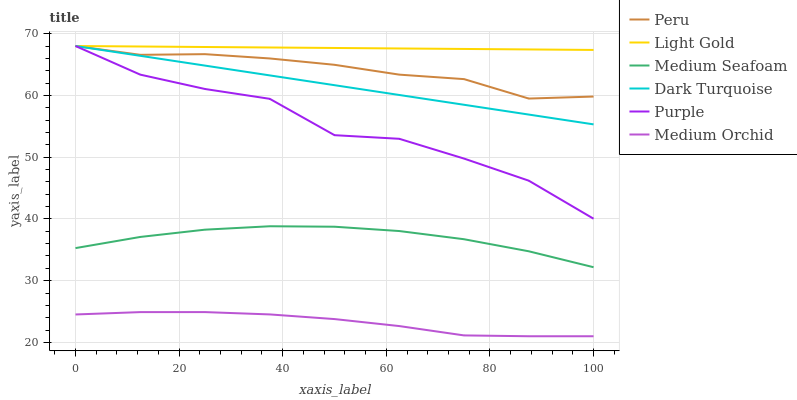Does Medium Orchid have the minimum area under the curve?
Answer yes or no. Yes. Does Light Gold have the maximum area under the curve?
Answer yes or no. Yes. Does Dark Turquoise have the minimum area under the curve?
Answer yes or no. No. Does Dark Turquoise have the maximum area under the curve?
Answer yes or no. No. Is Dark Turquoise the smoothest?
Answer yes or no. Yes. Is Purple the roughest?
Answer yes or no. Yes. Is Medium Orchid the smoothest?
Answer yes or no. No. Is Medium Orchid the roughest?
Answer yes or no. No. Does Dark Turquoise have the lowest value?
Answer yes or no. No. Does Light Gold have the highest value?
Answer yes or no. Yes. Does Medium Orchid have the highest value?
Answer yes or no. No. Is Medium Orchid less than Dark Turquoise?
Answer yes or no. Yes. Is Dark Turquoise greater than Medium Orchid?
Answer yes or no. Yes. Does Purple intersect Dark Turquoise?
Answer yes or no. Yes. Is Purple less than Dark Turquoise?
Answer yes or no. No. Is Purple greater than Dark Turquoise?
Answer yes or no. No. Does Medium Orchid intersect Dark Turquoise?
Answer yes or no. No. 